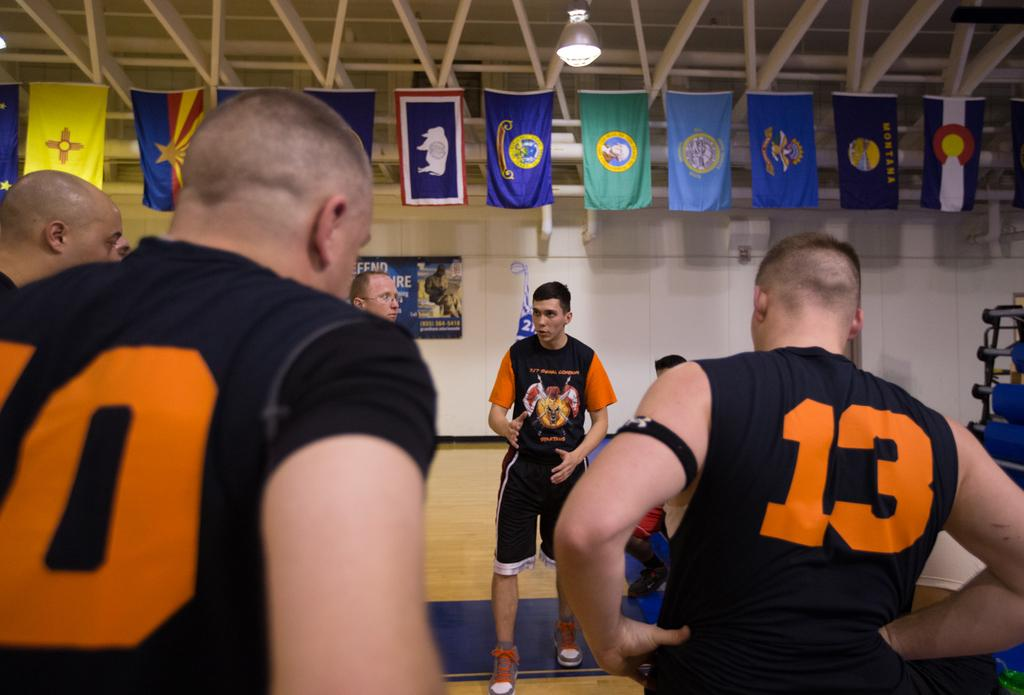<image>
Describe the image concisely. Player number 13 has a black arm band around his upper arm. 